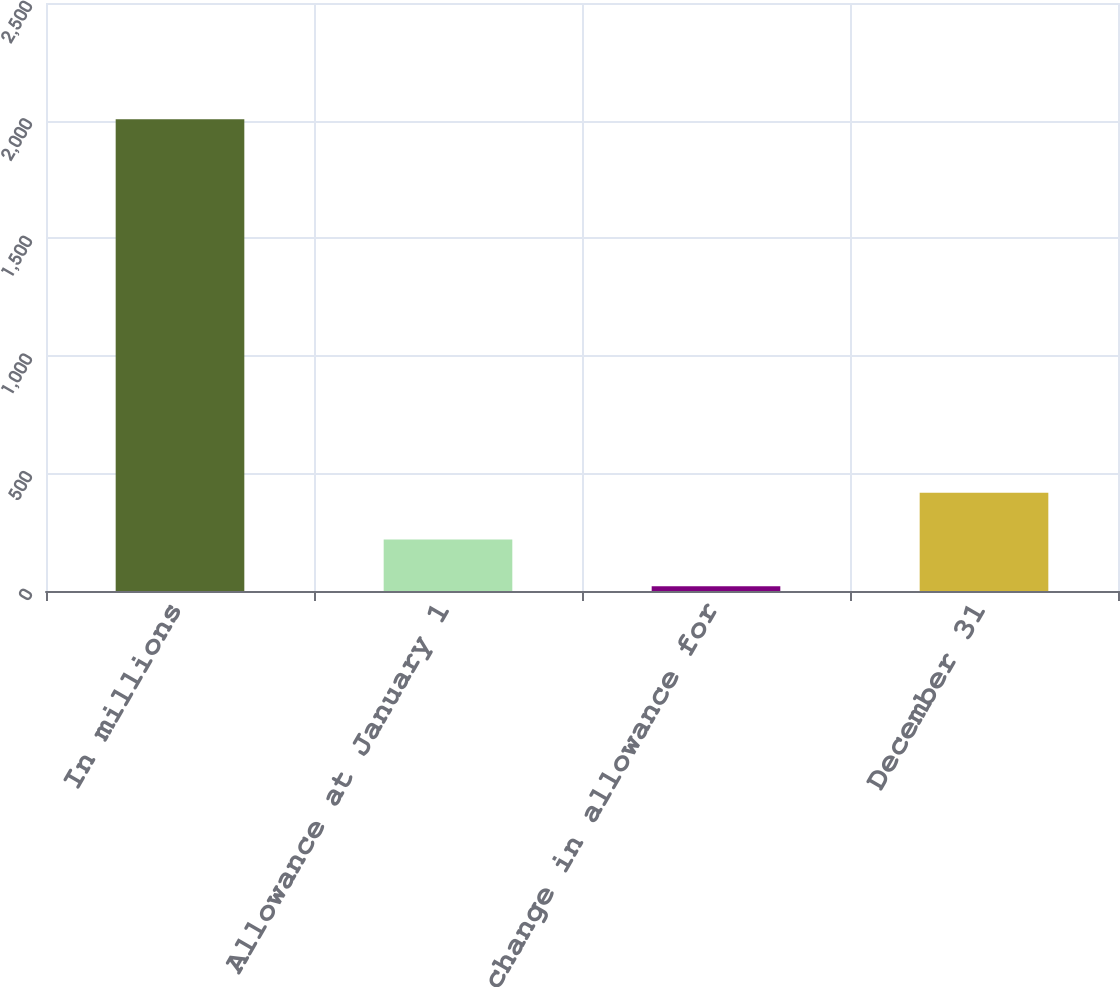<chart> <loc_0><loc_0><loc_500><loc_500><bar_chart><fcel>In millions<fcel>Allowance at January 1<fcel>Net change in allowance for<fcel>December 31<nl><fcel>2006<fcel>218.6<fcel>20<fcel>417.2<nl></chart> 